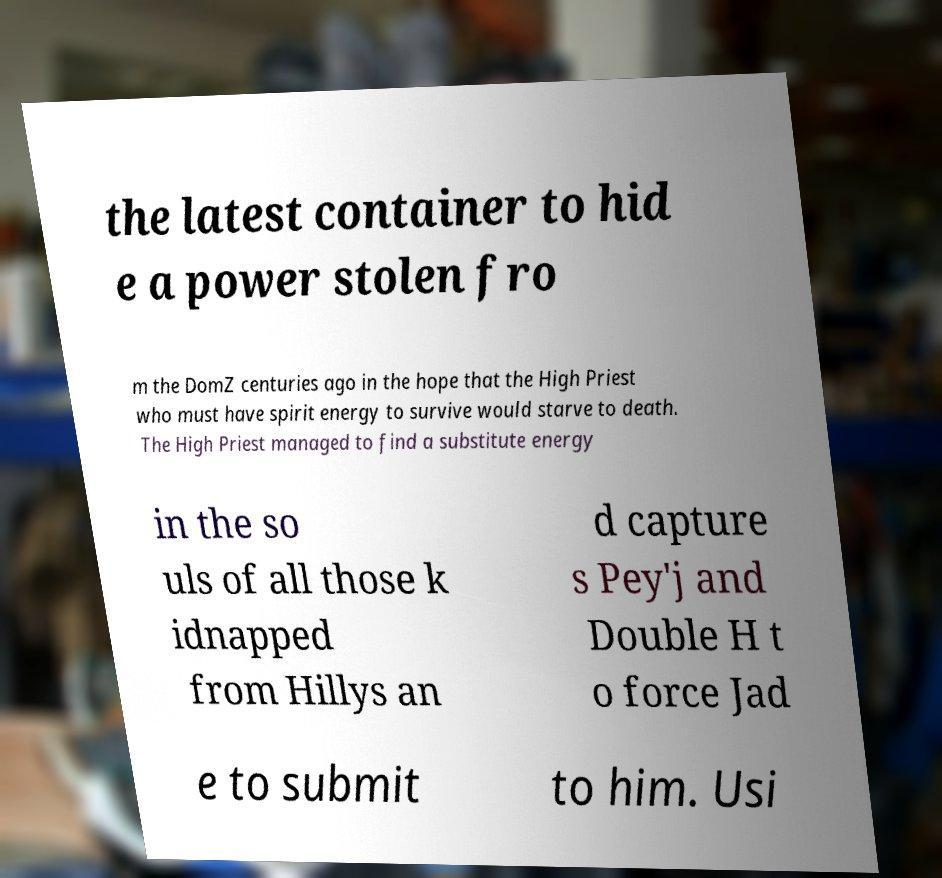What messages or text are displayed in this image? I need them in a readable, typed format. the latest container to hid e a power stolen fro m the DomZ centuries ago in the hope that the High Priest who must have spirit energy to survive would starve to death. The High Priest managed to find a substitute energy in the so uls of all those k idnapped from Hillys an d capture s Pey'j and Double H t o force Jad e to submit to him. Usi 